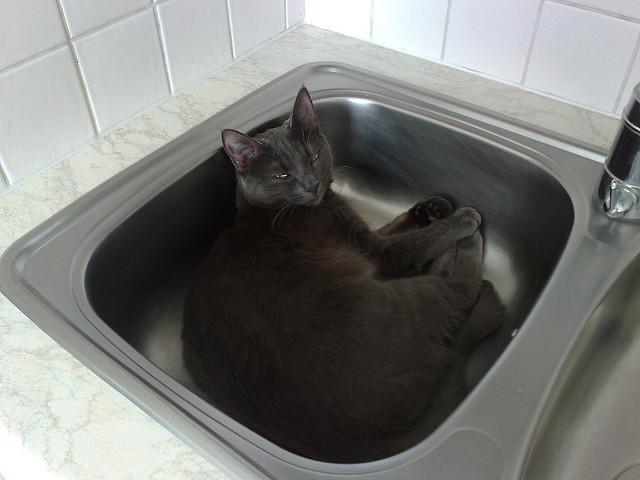What color is the cat in the sink?
Be succinct. Gray. Is the cat sleeping?
Write a very short answer. No. Is the cat about to have a bath?
Be succinct. No. 